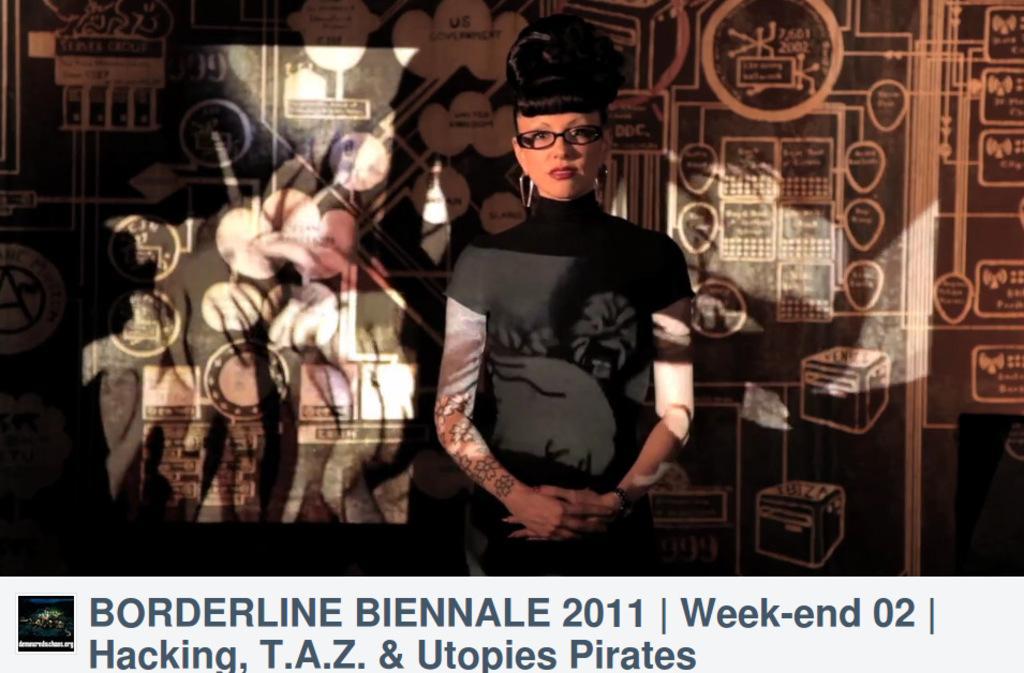Please provide a concise description of this image. In this image there is a woman. Behind her there is a wall with paintings and text on it. There is some text at the bottom of the image. 